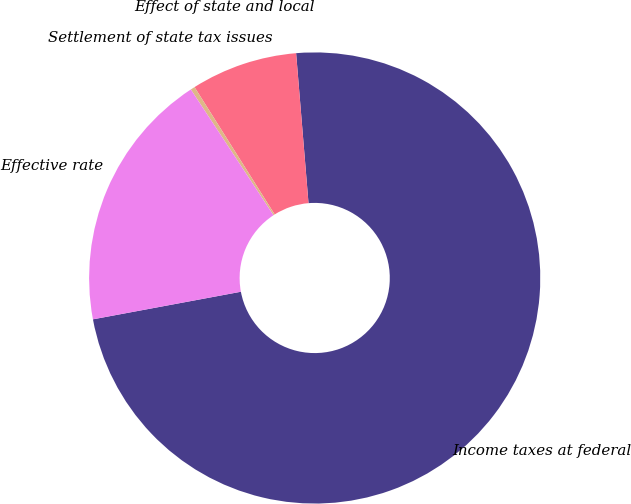<chart> <loc_0><loc_0><loc_500><loc_500><pie_chart><fcel>Income taxes at federal<fcel>Effect of state and local<fcel>Settlement of state tax issues<fcel>Effective rate<nl><fcel>73.38%<fcel>7.63%<fcel>0.31%<fcel>18.68%<nl></chart> 